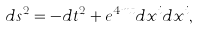Convert formula to latex. <formula><loc_0><loc_0><loc_500><loc_500>d s ^ { 2 } = - d t ^ { 2 } + e ^ { 4 m t } d x ^ { i } d x ^ { i } ,</formula> 